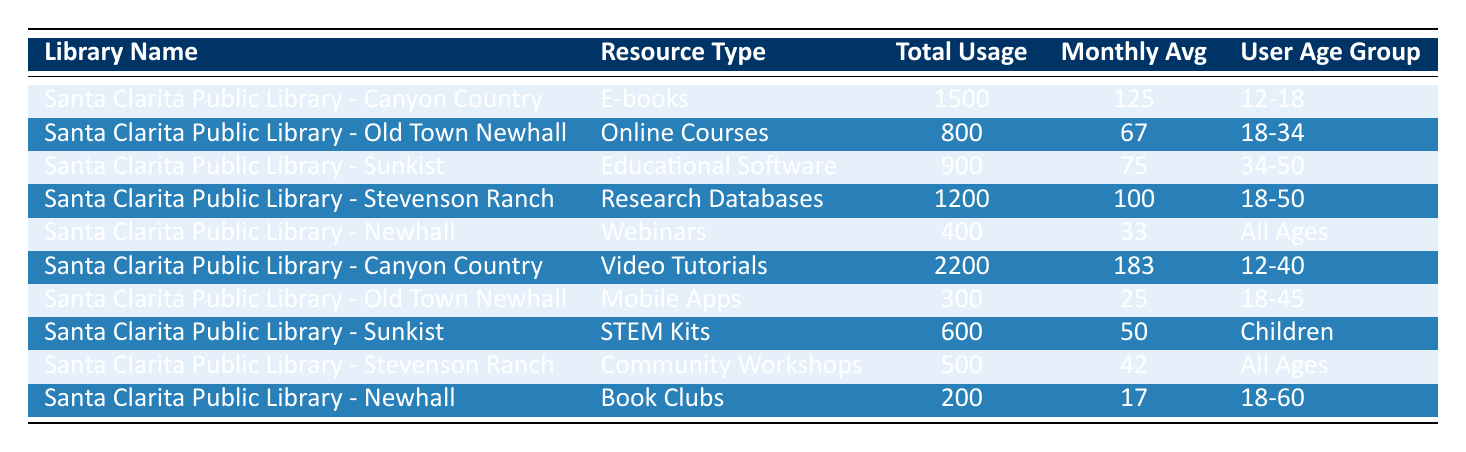What is the total number of video tutorial views at the Canyon Country Library? The table shows that the "Santa Clarita Public Library - Canyon Country" has a total of 2,200 views for video tutorials.
Answer: 2200 Which library offers mobile apps as a resource type? According to the table, "Santa Clarita Public Library - Old Town Newhall" offers mobile apps.
Answer: Old Town Newhall What is the average monthly attendance for community workshops at Stevenson Ranch? The table indicates that the total attendance for community workshops at "Santa Clarita Public Library - Stevenson Ranch" is 500, with a monthly average of 42.
Answer: 42 How many total checkouts were recorded for STEM kits in Santa Clarita Public Library - Sunkist? The data shows that the total checkouts for STEM kits at "Santa Clarita Public Library - Sunkist" were 600.
Answer: 600 Which resource type had the highest total usage? The total usage for video tutorials at the "Santa Clarita Public Library - Canyon Country" is 2,200, which is higher than other resources listed.
Answer: Video Tutorials What is the combined total for e-books and STEM kits checkouts? Adding the total checkouts for e-books (1,500) and STEM kits (600) gives 1,500 + 600 = 2,100.
Answer: 2100 Do any of the resources cater to all age groups? Yes, both webinars and community workshops are available for all age groups at the respective libraries.
Answer: Yes Which age group uses educational software at Sunkist? The table specifies the user age group for educational software at "Santa Clarita Public Library - Sunkist" as 34-50.
Answer: 34-50 Calculate the average total usage of all resource types listed. The total usage values are 1,500 (e-books) + 800 (online courses) + 900 (educational software) + 1,200 (research databases) + 400 (webinars) + 2,200 (video tutorials) + 300 (mobile apps) + 600 (STEM kits) + 500 (community workshops) + 200 (book clubs) = 8,100. There are 10 resource types, so the average is 8,100 / 10 = 810.
Answer: 810 Which library had the highest number of total enrollments for online courses? The table indicates that the "Santa Clarita Public Library - Old Town Newhall" had 800 total enrollments for online courses, the highest among the resources.
Answer: Old Town Newhall 